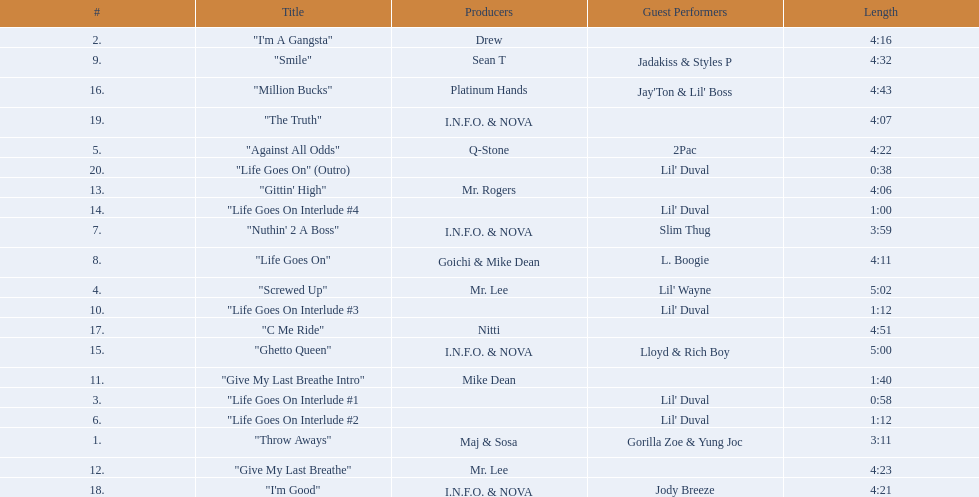What is the first track featuring lil' duval? "Life Goes On Interlude #1. 